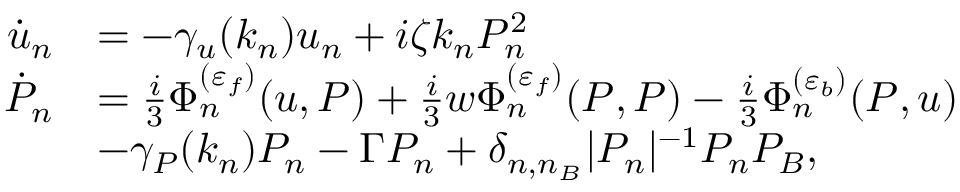<formula> <loc_0><loc_0><loc_500><loc_500>\begin{array} { r l } { \dot { u } _ { n } } & { = - \gamma _ { u } ( k _ { n } ) u _ { n } + i \zeta k _ { n } P _ { n } ^ { 2 } } \\ { \dot { P } _ { n } } & { = \frac { i } { 3 } \Phi _ { n } ^ { ( \varepsilon _ { f } ) } ( u , P ) + \frac { i } { 3 } w \Phi _ { n } ^ { ( \varepsilon _ { f } ) } ( P , P ) - \frac { i } { 3 } \Phi _ { n } ^ { ( \varepsilon _ { b } ) } ( P , u ) } \\ & { - \gamma _ { P } ( k _ { n } ) P _ { n } - \Gamma P _ { n } + \delta _ { n , n _ { B } } | P _ { n } | ^ { - 1 } P _ { n } P _ { B } , } \end{array}</formula> 